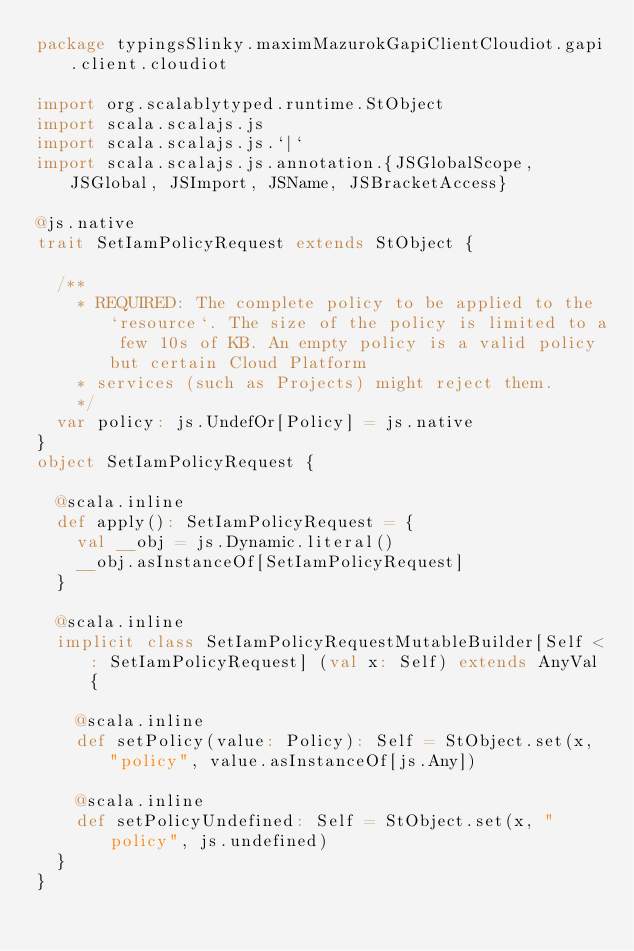Convert code to text. <code><loc_0><loc_0><loc_500><loc_500><_Scala_>package typingsSlinky.maximMazurokGapiClientCloudiot.gapi.client.cloudiot

import org.scalablytyped.runtime.StObject
import scala.scalajs.js
import scala.scalajs.js.`|`
import scala.scalajs.js.annotation.{JSGlobalScope, JSGlobal, JSImport, JSName, JSBracketAccess}

@js.native
trait SetIamPolicyRequest extends StObject {
  
  /**
    * REQUIRED: The complete policy to be applied to the `resource`. The size of the policy is limited to a few 10s of KB. An empty policy is a valid policy but certain Cloud Platform
    * services (such as Projects) might reject them.
    */
  var policy: js.UndefOr[Policy] = js.native
}
object SetIamPolicyRequest {
  
  @scala.inline
  def apply(): SetIamPolicyRequest = {
    val __obj = js.Dynamic.literal()
    __obj.asInstanceOf[SetIamPolicyRequest]
  }
  
  @scala.inline
  implicit class SetIamPolicyRequestMutableBuilder[Self <: SetIamPolicyRequest] (val x: Self) extends AnyVal {
    
    @scala.inline
    def setPolicy(value: Policy): Self = StObject.set(x, "policy", value.asInstanceOf[js.Any])
    
    @scala.inline
    def setPolicyUndefined: Self = StObject.set(x, "policy", js.undefined)
  }
}
</code> 